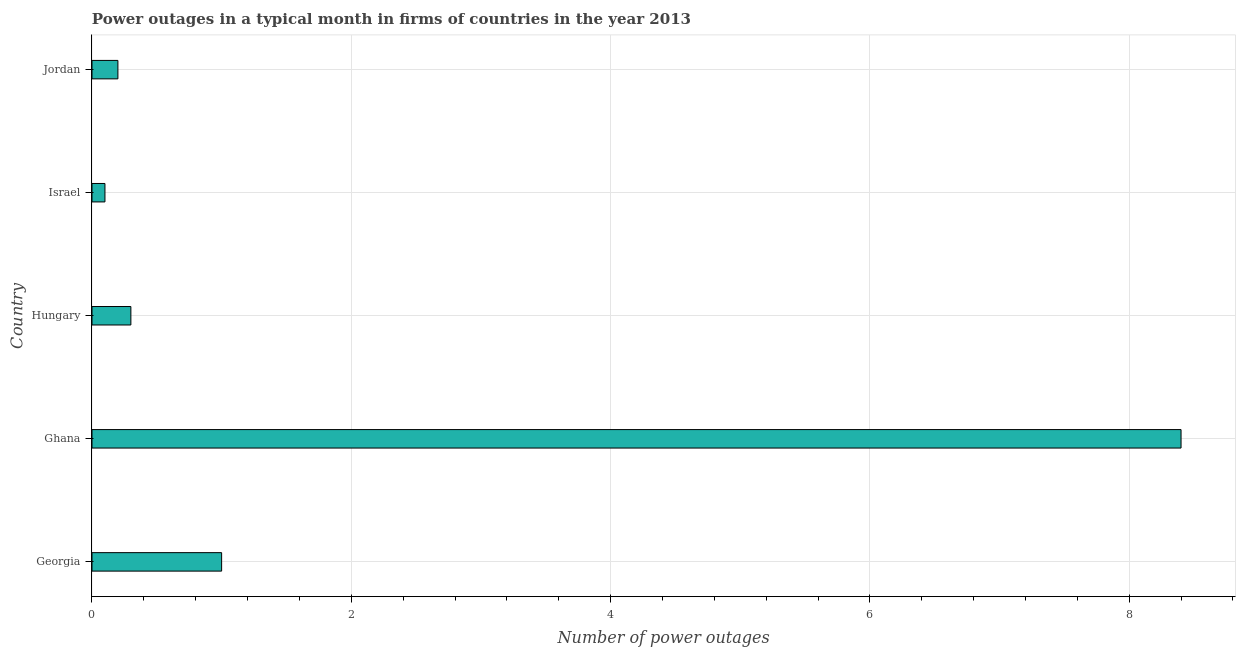Does the graph contain any zero values?
Ensure brevity in your answer.  No. What is the title of the graph?
Provide a succinct answer. Power outages in a typical month in firms of countries in the year 2013. What is the label or title of the X-axis?
Offer a terse response. Number of power outages. What is the label or title of the Y-axis?
Offer a terse response. Country. Across all countries, what is the minimum number of power outages?
Make the answer very short. 0.1. What is the sum of the number of power outages?
Offer a very short reply. 10. What is the average number of power outages per country?
Make the answer very short. 2. What is the ratio of the number of power outages in Georgia to that in Israel?
Make the answer very short. 10. Is the number of power outages in Georgia less than that in Israel?
Make the answer very short. No. Is the sum of the number of power outages in Georgia and Ghana greater than the maximum number of power outages across all countries?
Your response must be concise. Yes. What is the difference between the highest and the lowest number of power outages?
Make the answer very short. 8.3. In how many countries, is the number of power outages greater than the average number of power outages taken over all countries?
Your answer should be compact. 1. How many bars are there?
Make the answer very short. 5. Are all the bars in the graph horizontal?
Ensure brevity in your answer.  Yes. How many countries are there in the graph?
Make the answer very short. 5. What is the difference between two consecutive major ticks on the X-axis?
Provide a succinct answer. 2. Are the values on the major ticks of X-axis written in scientific E-notation?
Make the answer very short. No. What is the Number of power outages in Georgia?
Offer a terse response. 1. What is the Number of power outages of Jordan?
Keep it short and to the point. 0.2. What is the difference between the Number of power outages in Georgia and Jordan?
Your response must be concise. 0.8. What is the difference between the Number of power outages in Ghana and Hungary?
Ensure brevity in your answer.  8.1. What is the difference between the Number of power outages in Hungary and Israel?
Your answer should be compact. 0.2. What is the ratio of the Number of power outages in Georgia to that in Ghana?
Offer a very short reply. 0.12. What is the ratio of the Number of power outages in Georgia to that in Hungary?
Your answer should be very brief. 3.33. What is the ratio of the Number of power outages in Georgia to that in Israel?
Your answer should be compact. 10. What is the ratio of the Number of power outages in Ghana to that in Hungary?
Provide a short and direct response. 28. What is the ratio of the Number of power outages in Ghana to that in Israel?
Your response must be concise. 84. 